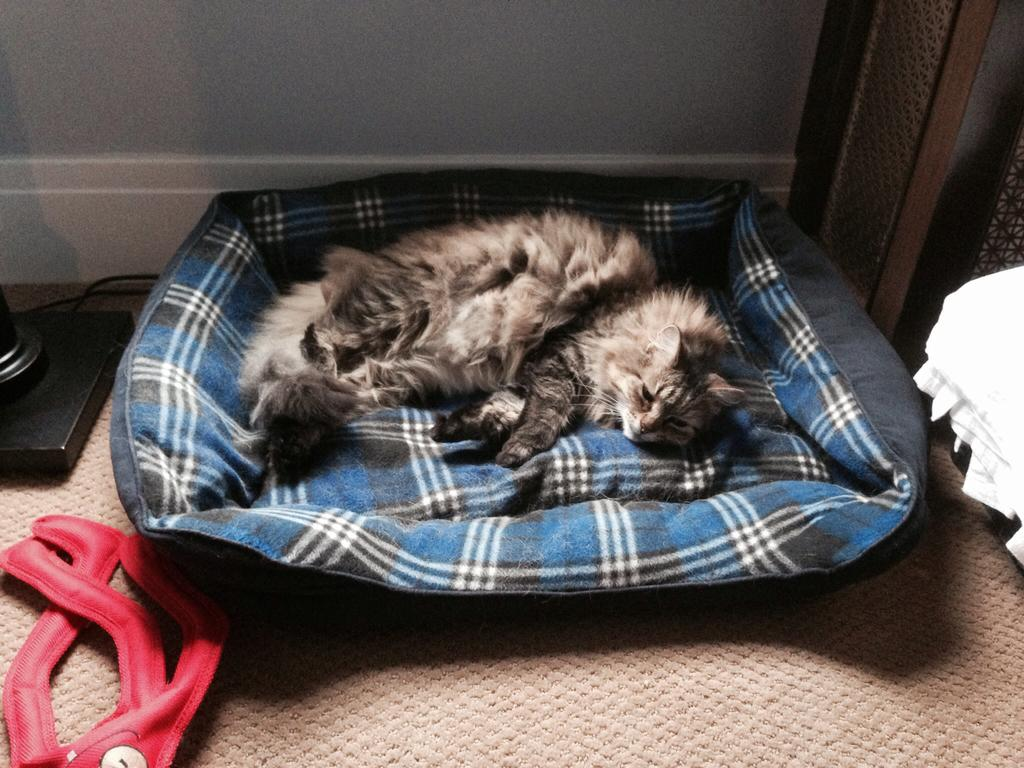What type of furniture is in the image? There is an animal bed in the image. What animals are on the bed? There are cats lying on the bed. What colors are the objects on the floor? The objects on the floor are red and black in color. What can be seen in the background of the image? There is a wall visible in the background of the image. What grade is the cat in the image? The image does not provide information about the cat's grade, as it is not relevant to the image. 